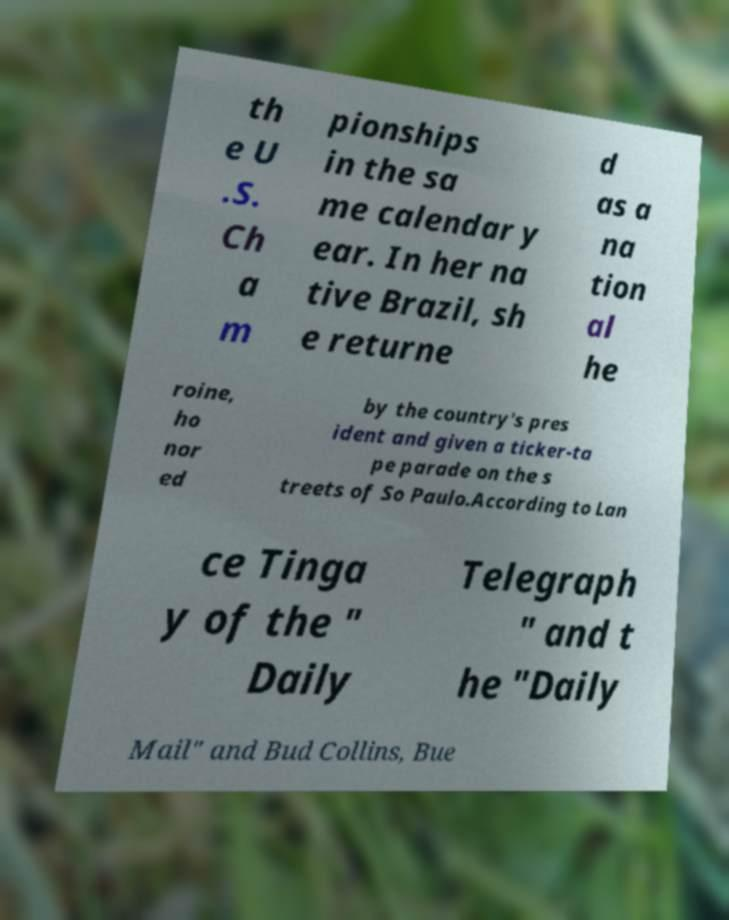For documentation purposes, I need the text within this image transcribed. Could you provide that? th e U .S. Ch a m pionships in the sa me calendar y ear. In her na tive Brazil, sh e returne d as a na tion al he roine, ho nor ed by the country's pres ident and given a ticker-ta pe parade on the s treets of So Paulo.According to Lan ce Tinga y of the " Daily Telegraph " and t he "Daily Mail" and Bud Collins, Bue 